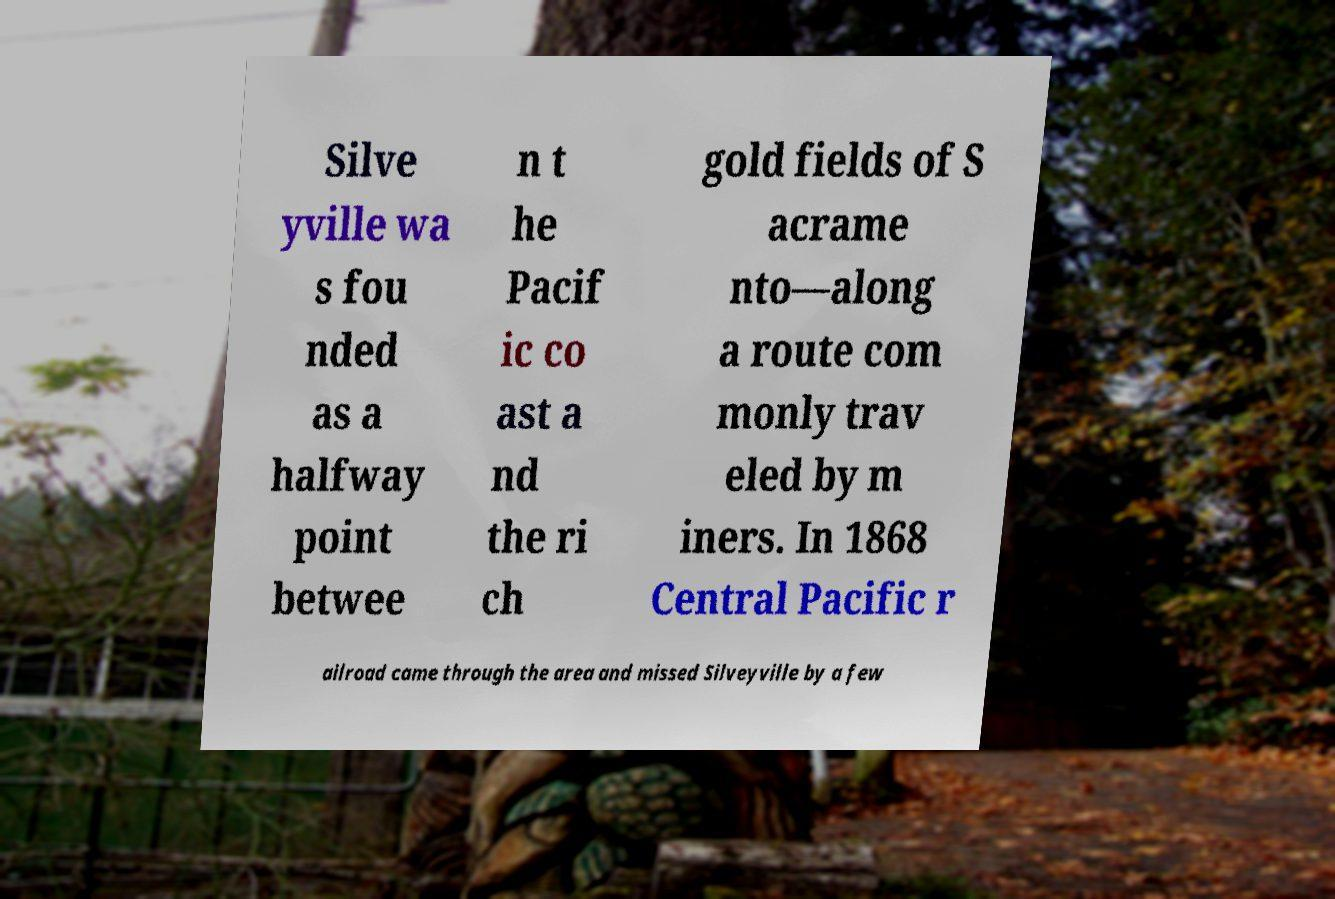Could you assist in decoding the text presented in this image and type it out clearly? Silve yville wa s fou nded as a halfway point betwee n t he Pacif ic co ast a nd the ri ch gold fields of S acrame nto—along a route com monly trav eled by m iners. In 1868 Central Pacific r ailroad came through the area and missed Silveyville by a few 